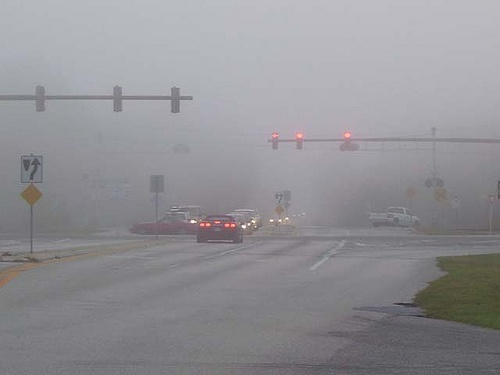Describe the objects in this image and their specific colors. I can see car in darkgray and gray tones, car in darkgray and gray tones, car in darkgray and gray tones, car in darkgray and gray tones, and traffic light in darkgray and gray tones in this image. 